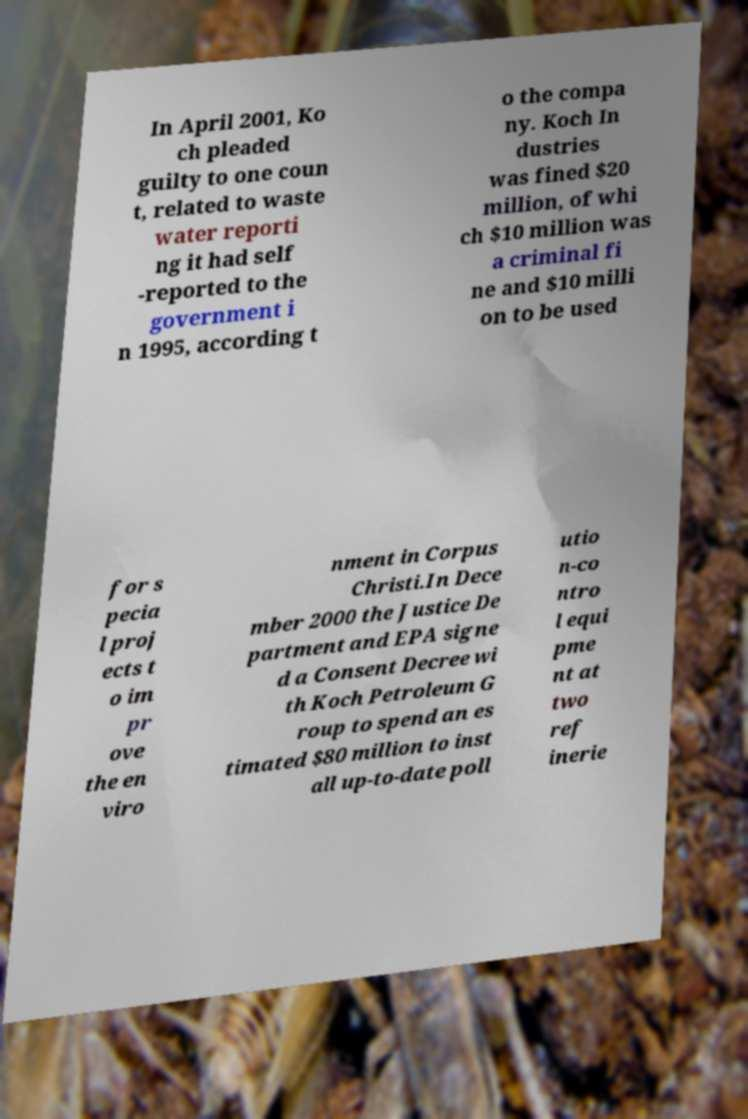I need the written content from this picture converted into text. Can you do that? In April 2001, Ko ch pleaded guilty to one coun t, related to waste water reporti ng it had self -reported to the government i n 1995, according t o the compa ny. Koch In dustries was fined $20 million, of whi ch $10 million was a criminal fi ne and $10 milli on to be used for s pecia l proj ects t o im pr ove the en viro nment in Corpus Christi.In Dece mber 2000 the Justice De partment and EPA signe d a Consent Decree wi th Koch Petroleum G roup to spend an es timated $80 million to inst all up-to-date poll utio n-co ntro l equi pme nt at two ref inerie 